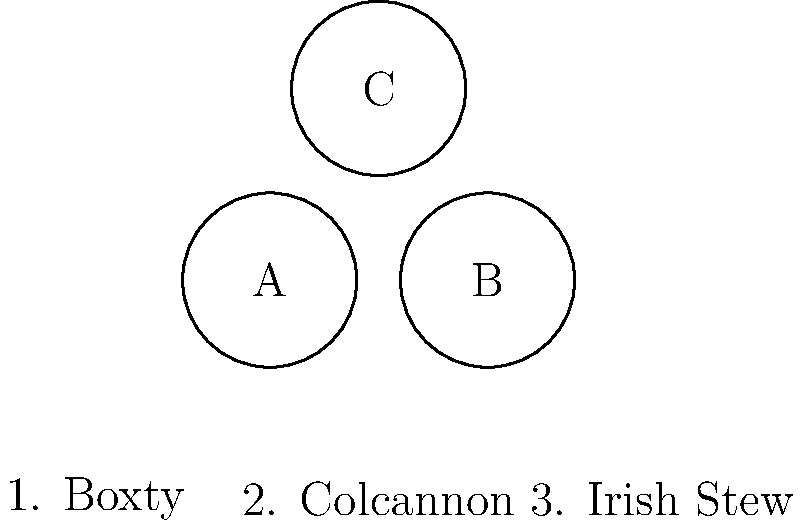Match the traditional Irish dishes (1-3) with their visual representations (A-C) based on their typical appearance and ingredients. To match the traditional Irish dishes with their visual representations, we need to consider the typical appearance and ingredients of each dish:

1. Boxty: This is a traditional Irish potato pancake. It would typically appear as a flat, round, golden-brown pancake made from grated potatoes, flour, and milk. This best matches image A, which shows a circular shape resembling a pancake.

2. Colcannon: This dish is made from mashed potatoes mixed with kale or cabbage. It would appear as a green-flecked, creamy mashed potato dish. This best matches image C, which shows a circular shape with a mottled appearance, suggesting the mixture of potatoes and greens.

3. Irish Stew: This is a hearty meat and vegetable stew, typically made with lamb, potatoes, carrots, and other vegetables. It would appear as a bowl of chunky, broth-based stew. This best matches image B, which shows a circular shape with a more complex interior, suggesting the various ingredients in a stew.

Therefore, the correct matching is:
1 (Boxty) - A
2 (Colcannon) - C
3 (Irish Stew) - B
Answer: 1-A, 2-C, 3-B 